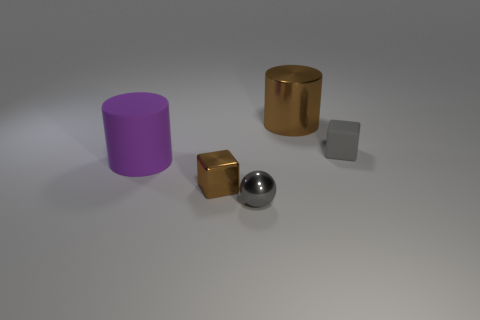How many big things are both behind the small gray matte thing and in front of the gray cube?
Give a very brief answer. 0. How many cylinders are big blue shiny things or big matte things?
Your response must be concise. 1. Is there a large sphere?
Provide a succinct answer. No. How many other things are made of the same material as the gray block?
Provide a succinct answer. 1. There is a gray object that is the same size as the gray sphere; what is it made of?
Your answer should be compact. Rubber. Does the brown object that is to the left of the brown cylinder have the same shape as the purple matte thing?
Provide a short and direct response. No. Is the color of the shiny ball the same as the tiny rubber thing?
Offer a very short reply. Yes. How many objects are gray objects that are behind the purple thing or gray blocks?
Offer a terse response. 1. The brown metal thing that is the same size as the gray sphere is what shape?
Provide a succinct answer. Cube. Does the cylinder in front of the gray rubber cube have the same size as the brown shiny thing in front of the small matte thing?
Make the answer very short. No. 